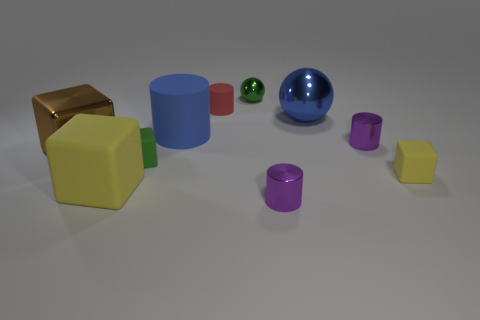Subtract all blocks. How many objects are left? 6 Add 6 small red matte objects. How many small red matte objects exist? 7 Subtract 0 red spheres. How many objects are left? 10 Subtract all large yellow blocks. Subtract all big blue things. How many objects are left? 7 Add 6 tiny purple cylinders. How many tiny purple cylinders are left? 8 